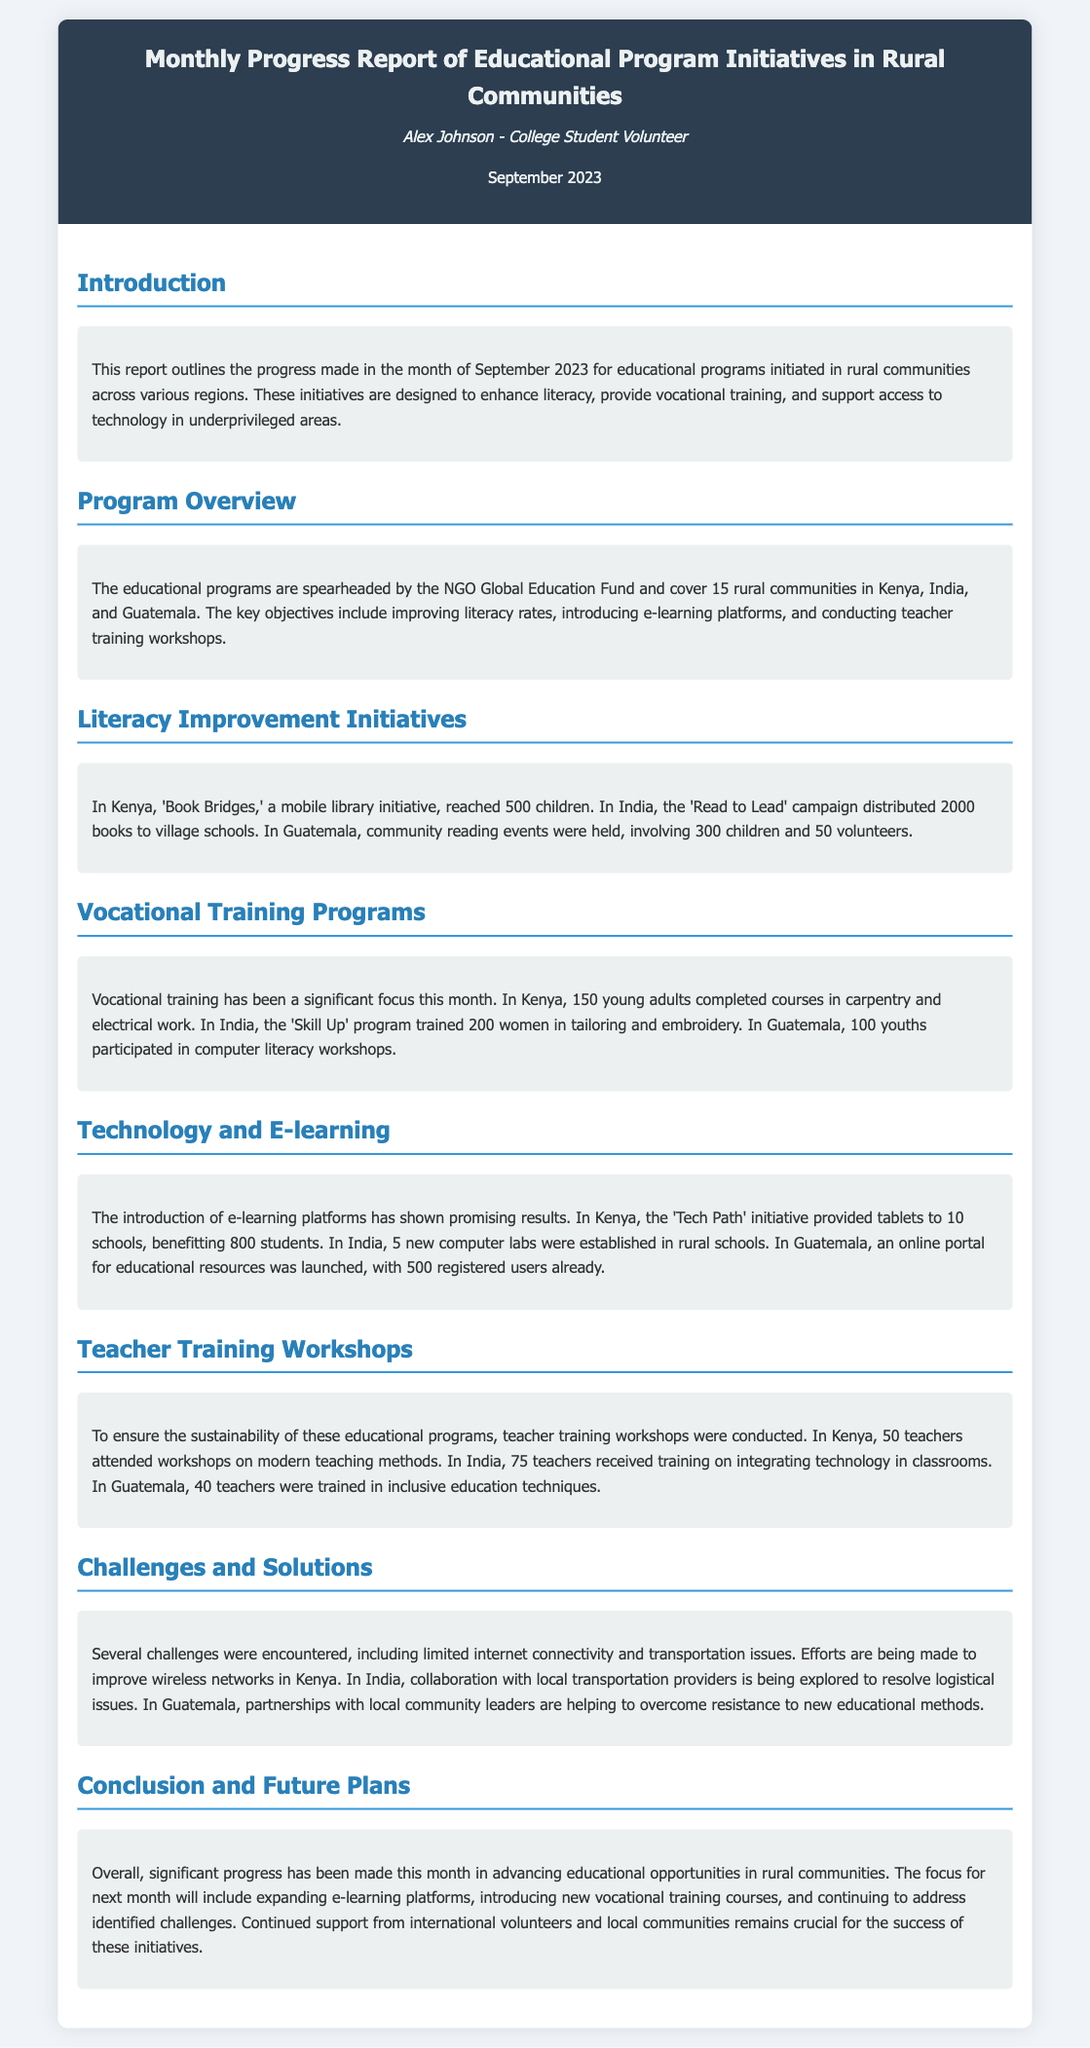What is the name of the NGO leading the initiatives? The document states that the NGO leading the initiatives is the Global Education Fund.
Answer: Global Education Fund How many rural communities are covered by the programs? According to the document, the educational programs cover 15 rural communities.
Answer: 15 How many books were distributed in India during the 'Read to Lead' campaign? The report mentions that 2000 books were distributed to village schools in India.
Answer: 2000 How many young adults completed vocational training courses in Kenya? In Kenya, the report indicates that 150 young adults completed courses in carpentry and electrical work.
Answer: 150 What technological initiative provided tablets to schools in Kenya? The initiative mentioned in the document that provided tablets is called 'Tech Path'.
Answer: Tech Path What challenges did the report highlight regarding internet connectivity? The document highlights limited internet connectivity as a challenge encountered.
Answer: Limited internet connectivity How many teachers attended workshops on modern teaching methods in Kenya? According to the document, 50 teachers attended workshops on modern teaching methods in Kenya.
Answer: 50 What is the focus for next month according to the conclusion? The focus for next month includes expanding e-learning platforms as mentioned in the conclusion section.
Answer: Expanding e-learning platforms How many youths participated in computer literacy workshops in Guatemala? The report states that 100 youths participated in computer literacy workshops in Guatemala.
Answer: 100 How many registered users does the online educational portal in Guatemala have? The online portal for educational resources in Guatemala has 500 registered users as per the document.
Answer: 500 